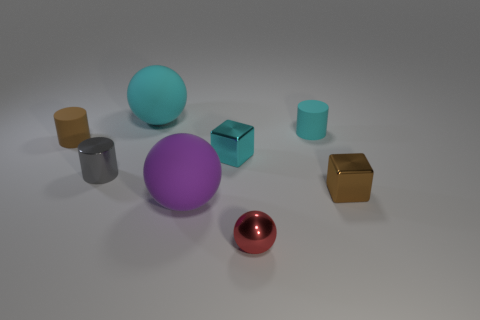There is a red object; does it have the same size as the cylinder right of the small red metal ball?
Ensure brevity in your answer.  Yes. How many spheres are large purple matte objects or tiny things?
Provide a succinct answer. 2. What number of tiny things are both to the left of the gray metal thing and in front of the big purple matte ball?
Ensure brevity in your answer.  0. What shape is the small cyan matte object that is right of the small gray shiny thing?
Ensure brevity in your answer.  Cylinder. Are the brown block and the small red thing made of the same material?
Provide a short and direct response. Yes. Is there any other thing that has the same size as the gray thing?
Ensure brevity in your answer.  Yes. There is a brown metal object; what number of small objects are to the left of it?
Keep it short and to the point. 5. There is a brown object that is right of the big thing on the left side of the big purple rubber sphere; what shape is it?
Ensure brevity in your answer.  Cube. Is there anything else that has the same shape as the purple matte thing?
Offer a terse response. Yes. Are there more big purple rubber objects that are on the right side of the gray metallic cylinder than large purple rubber balls?
Make the answer very short. No. 